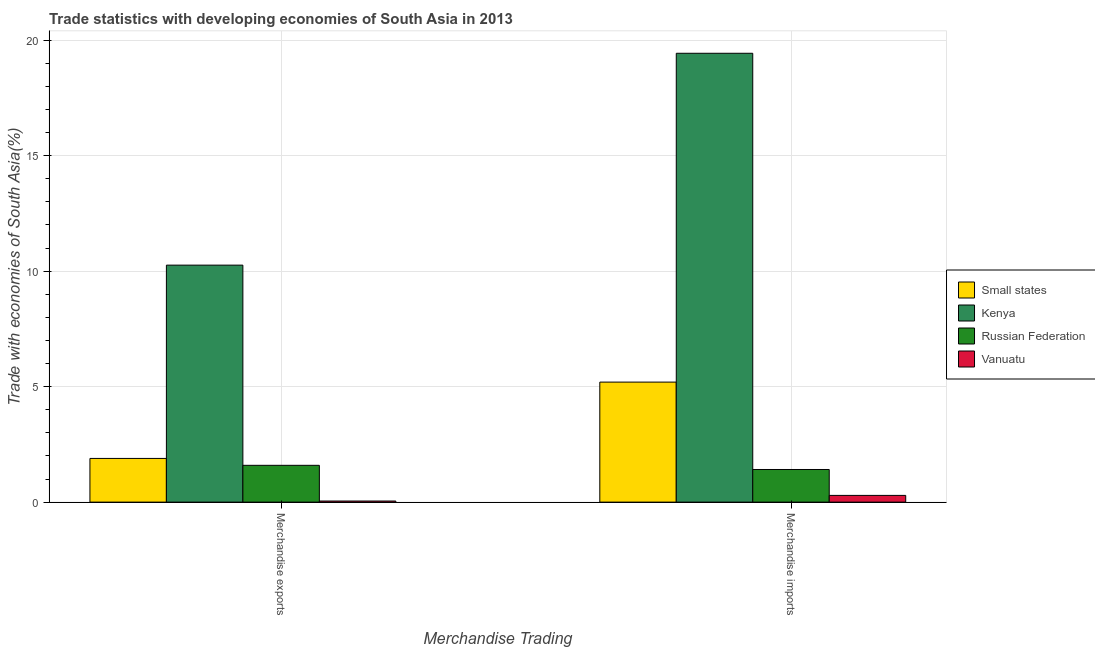How many groups of bars are there?
Offer a very short reply. 2. Are the number of bars on each tick of the X-axis equal?
Provide a short and direct response. Yes. What is the label of the 1st group of bars from the left?
Provide a succinct answer. Merchandise exports. What is the merchandise exports in Small states?
Provide a succinct answer. 1.89. Across all countries, what is the maximum merchandise exports?
Your answer should be compact. 10.26. Across all countries, what is the minimum merchandise imports?
Offer a very short reply. 0.29. In which country was the merchandise exports maximum?
Your answer should be very brief. Kenya. In which country was the merchandise imports minimum?
Your answer should be very brief. Vanuatu. What is the total merchandise exports in the graph?
Your response must be concise. 13.79. What is the difference between the merchandise exports in Vanuatu and that in Kenya?
Your answer should be compact. -10.21. What is the difference between the merchandise imports in Vanuatu and the merchandise exports in Russian Federation?
Provide a short and direct response. -1.3. What is the average merchandise imports per country?
Keep it short and to the point. 6.58. What is the difference between the merchandise imports and merchandise exports in Vanuatu?
Keep it short and to the point. 0.24. In how many countries, is the merchandise exports greater than 12 %?
Offer a very short reply. 0. What is the ratio of the merchandise exports in Vanuatu to that in Kenya?
Provide a short and direct response. 0. In how many countries, is the merchandise exports greater than the average merchandise exports taken over all countries?
Your response must be concise. 1. What does the 1st bar from the left in Merchandise exports represents?
Your response must be concise. Small states. What does the 4th bar from the right in Merchandise exports represents?
Your response must be concise. Small states. How many countries are there in the graph?
Provide a succinct answer. 4. What is the difference between two consecutive major ticks on the Y-axis?
Offer a very short reply. 5. Are the values on the major ticks of Y-axis written in scientific E-notation?
Give a very brief answer. No. Does the graph contain any zero values?
Your answer should be very brief. No. Does the graph contain grids?
Keep it short and to the point. Yes. Where does the legend appear in the graph?
Your response must be concise. Center right. What is the title of the graph?
Offer a terse response. Trade statistics with developing economies of South Asia in 2013. What is the label or title of the X-axis?
Offer a terse response. Merchandise Trading. What is the label or title of the Y-axis?
Your answer should be very brief. Trade with economies of South Asia(%). What is the Trade with economies of South Asia(%) in Small states in Merchandise exports?
Your answer should be compact. 1.89. What is the Trade with economies of South Asia(%) of Kenya in Merchandise exports?
Offer a terse response. 10.26. What is the Trade with economies of South Asia(%) in Russian Federation in Merchandise exports?
Provide a short and direct response. 1.59. What is the Trade with economies of South Asia(%) of Vanuatu in Merchandise exports?
Make the answer very short. 0.05. What is the Trade with economies of South Asia(%) in Small states in Merchandise imports?
Keep it short and to the point. 5.2. What is the Trade with economies of South Asia(%) in Kenya in Merchandise imports?
Offer a very short reply. 19.43. What is the Trade with economies of South Asia(%) in Russian Federation in Merchandise imports?
Your answer should be very brief. 1.41. What is the Trade with economies of South Asia(%) of Vanuatu in Merchandise imports?
Keep it short and to the point. 0.29. Across all Merchandise Trading, what is the maximum Trade with economies of South Asia(%) in Small states?
Make the answer very short. 5.2. Across all Merchandise Trading, what is the maximum Trade with economies of South Asia(%) of Kenya?
Ensure brevity in your answer.  19.43. Across all Merchandise Trading, what is the maximum Trade with economies of South Asia(%) of Russian Federation?
Provide a succinct answer. 1.59. Across all Merchandise Trading, what is the maximum Trade with economies of South Asia(%) in Vanuatu?
Provide a short and direct response. 0.29. Across all Merchandise Trading, what is the minimum Trade with economies of South Asia(%) of Small states?
Ensure brevity in your answer.  1.89. Across all Merchandise Trading, what is the minimum Trade with economies of South Asia(%) of Kenya?
Offer a very short reply. 10.26. Across all Merchandise Trading, what is the minimum Trade with economies of South Asia(%) of Russian Federation?
Your response must be concise. 1.41. Across all Merchandise Trading, what is the minimum Trade with economies of South Asia(%) in Vanuatu?
Offer a very short reply. 0.05. What is the total Trade with economies of South Asia(%) in Small states in the graph?
Offer a very short reply. 7.09. What is the total Trade with economies of South Asia(%) in Kenya in the graph?
Offer a terse response. 29.69. What is the total Trade with economies of South Asia(%) in Russian Federation in the graph?
Offer a very short reply. 3.01. What is the total Trade with economies of South Asia(%) in Vanuatu in the graph?
Keep it short and to the point. 0.34. What is the difference between the Trade with economies of South Asia(%) in Small states in Merchandise exports and that in Merchandise imports?
Your answer should be very brief. -3.3. What is the difference between the Trade with economies of South Asia(%) of Kenya in Merchandise exports and that in Merchandise imports?
Your answer should be very brief. -9.17. What is the difference between the Trade with economies of South Asia(%) of Russian Federation in Merchandise exports and that in Merchandise imports?
Keep it short and to the point. 0.18. What is the difference between the Trade with economies of South Asia(%) of Vanuatu in Merchandise exports and that in Merchandise imports?
Offer a terse response. -0.24. What is the difference between the Trade with economies of South Asia(%) of Small states in Merchandise exports and the Trade with economies of South Asia(%) of Kenya in Merchandise imports?
Offer a terse response. -17.54. What is the difference between the Trade with economies of South Asia(%) of Small states in Merchandise exports and the Trade with economies of South Asia(%) of Russian Federation in Merchandise imports?
Provide a short and direct response. 0.48. What is the difference between the Trade with economies of South Asia(%) of Small states in Merchandise exports and the Trade with economies of South Asia(%) of Vanuatu in Merchandise imports?
Ensure brevity in your answer.  1.6. What is the difference between the Trade with economies of South Asia(%) of Kenya in Merchandise exports and the Trade with economies of South Asia(%) of Russian Federation in Merchandise imports?
Provide a succinct answer. 8.85. What is the difference between the Trade with economies of South Asia(%) in Kenya in Merchandise exports and the Trade with economies of South Asia(%) in Vanuatu in Merchandise imports?
Ensure brevity in your answer.  9.97. What is the difference between the Trade with economies of South Asia(%) in Russian Federation in Merchandise exports and the Trade with economies of South Asia(%) in Vanuatu in Merchandise imports?
Provide a short and direct response. 1.3. What is the average Trade with economies of South Asia(%) in Small states per Merchandise Trading?
Ensure brevity in your answer.  3.54. What is the average Trade with economies of South Asia(%) of Kenya per Merchandise Trading?
Your response must be concise. 14.85. What is the average Trade with economies of South Asia(%) of Russian Federation per Merchandise Trading?
Your response must be concise. 1.5. What is the average Trade with economies of South Asia(%) of Vanuatu per Merchandise Trading?
Provide a short and direct response. 0.17. What is the difference between the Trade with economies of South Asia(%) in Small states and Trade with economies of South Asia(%) in Kenya in Merchandise exports?
Offer a terse response. -8.37. What is the difference between the Trade with economies of South Asia(%) of Small states and Trade with economies of South Asia(%) of Russian Federation in Merchandise exports?
Provide a succinct answer. 0.3. What is the difference between the Trade with economies of South Asia(%) in Small states and Trade with economies of South Asia(%) in Vanuatu in Merchandise exports?
Keep it short and to the point. 1.84. What is the difference between the Trade with economies of South Asia(%) of Kenya and Trade with economies of South Asia(%) of Russian Federation in Merchandise exports?
Offer a very short reply. 8.67. What is the difference between the Trade with economies of South Asia(%) in Kenya and Trade with economies of South Asia(%) in Vanuatu in Merchandise exports?
Provide a short and direct response. 10.21. What is the difference between the Trade with economies of South Asia(%) in Russian Federation and Trade with economies of South Asia(%) in Vanuatu in Merchandise exports?
Keep it short and to the point. 1.55. What is the difference between the Trade with economies of South Asia(%) of Small states and Trade with economies of South Asia(%) of Kenya in Merchandise imports?
Your answer should be very brief. -14.24. What is the difference between the Trade with economies of South Asia(%) in Small states and Trade with economies of South Asia(%) in Russian Federation in Merchandise imports?
Give a very brief answer. 3.78. What is the difference between the Trade with economies of South Asia(%) in Small states and Trade with economies of South Asia(%) in Vanuatu in Merchandise imports?
Provide a short and direct response. 4.9. What is the difference between the Trade with economies of South Asia(%) in Kenya and Trade with economies of South Asia(%) in Russian Federation in Merchandise imports?
Keep it short and to the point. 18.02. What is the difference between the Trade with economies of South Asia(%) of Kenya and Trade with economies of South Asia(%) of Vanuatu in Merchandise imports?
Provide a short and direct response. 19.14. What is the difference between the Trade with economies of South Asia(%) of Russian Federation and Trade with economies of South Asia(%) of Vanuatu in Merchandise imports?
Make the answer very short. 1.12. What is the ratio of the Trade with economies of South Asia(%) of Small states in Merchandise exports to that in Merchandise imports?
Ensure brevity in your answer.  0.36. What is the ratio of the Trade with economies of South Asia(%) of Kenya in Merchandise exports to that in Merchandise imports?
Provide a succinct answer. 0.53. What is the ratio of the Trade with economies of South Asia(%) in Russian Federation in Merchandise exports to that in Merchandise imports?
Provide a succinct answer. 1.13. What is the ratio of the Trade with economies of South Asia(%) in Vanuatu in Merchandise exports to that in Merchandise imports?
Provide a short and direct response. 0.16. What is the difference between the highest and the second highest Trade with economies of South Asia(%) in Small states?
Offer a very short reply. 3.3. What is the difference between the highest and the second highest Trade with economies of South Asia(%) of Kenya?
Provide a succinct answer. 9.17. What is the difference between the highest and the second highest Trade with economies of South Asia(%) in Russian Federation?
Your answer should be compact. 0.18. What is the difference between the highest and the second highest Trade with economies of South Asia(%) of Vanuatu?
Ensure brevity in your answer.  0.24. What is the difference between the highest and the lowest Trade with economies of South Asia(%) of Small states?
Keep it short and to the point. 3.3. What is the difference between the highest and the lowest Trade with economies of South Asia(%) of Kenya?
Make the answer very short. 9.17. What is the difference between the highest and the lowest Trade with economies of South Asia(%) of Russian Federation?
Your answer should be compact. 0.18. What is the difference between the highest and the lowest Trade with economies of South Asia(%) of Vanuatu?
Provide a succinct answer. 0.24. 